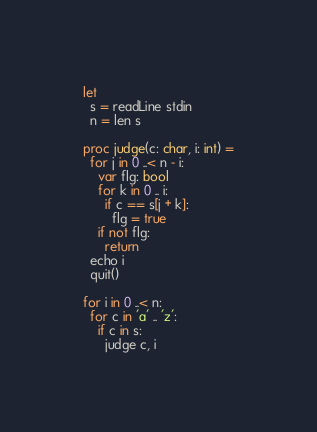<code> <loc_0><loc_0><loc_500><loc_500><_Nim_>let
  s = readLine stdin
  n = len s

proc judge(c: char, i: int) =
  for j in 0 ..< n - i:
    var flg: bool
    for k in 0 .. i:
      if c == s[j + k]:
        flg = true
    if not flg:
      return
  echo i
  quit()

for i in 0 ..< n:
  for c in 'a' .. 'z':
    if c in s:
      judge c, i
</code> 